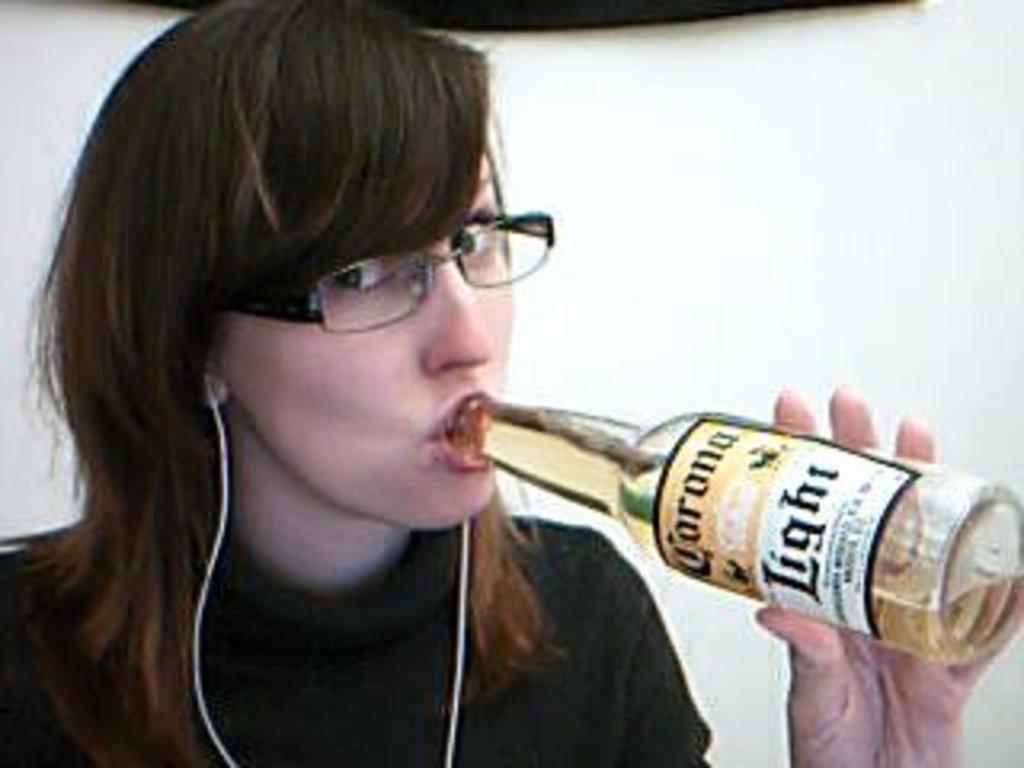Can you describe this image briefly? In this image we can see a girl is holding a bottle and drinking it. There is a label on the bottle. 